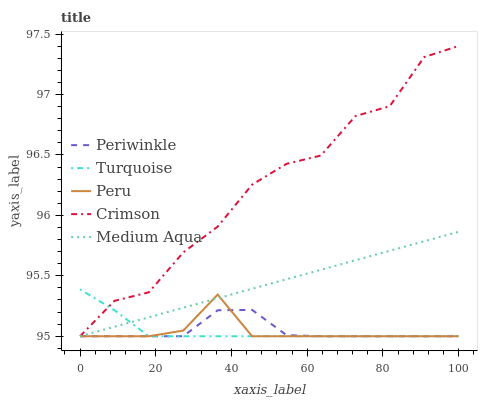Does Peru have the minimum area under the curve?
Answer yes or no. Yes. Does Crimson have the maximum area under the curve?
Answer yes or no. Yes. Does Medium Aqua have the minimum area under the curve?
Answer yes or no. No. Does Medium Aqua have the maximum area under the curve?
Answer yes or no. No. Is Medium Aqua the smoothest?
Answer yes or no. Yes. Is Crimson the roughest?
Answer yes or no. Yes. Is Turquoise the smoothest?
Answer yes or no. No. Is Turquoise the roughest?
Answer yes or no. No. Does Crimson have the lowest value?
Answer yes or no. Yes. Does Crimson have the highest value?
Answer yes or no. Yes. Does Medium Aqua have the highest value?
Answer yes or no. No. Does Medium Aqua intersect Turquoise?
Answer yes or no. Yes. Is Medium Aqua less than Turquoise?
Answer yes or no. No. Is Medium Aqua greater than Turquoise?
Answer yes or no. No. 